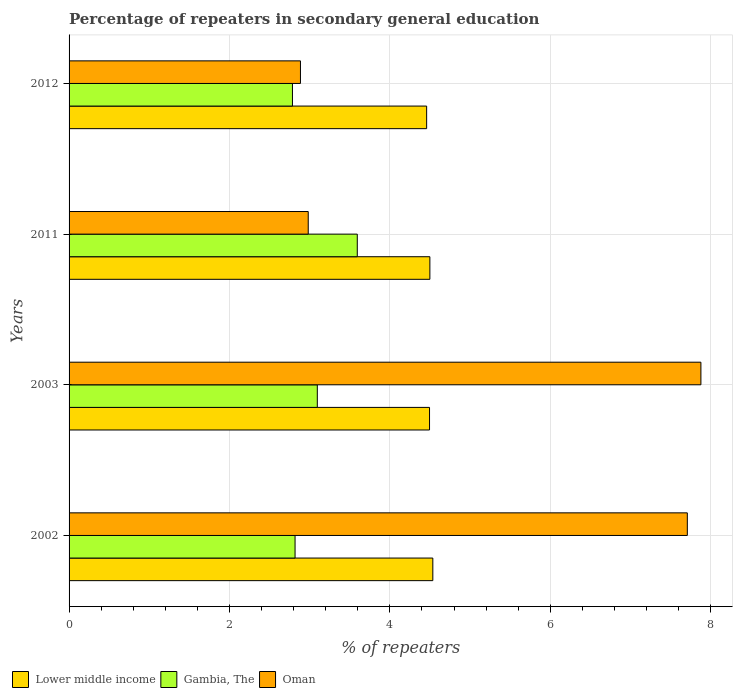How many different coloured bars are there?
Offer a terse response. 3. In how many cases, is the number of bars for a given year not equal to the number of legend labels?
Give a very brief answer. 0. What is the percentage of repeaters in secondary general education in Oman in 2012?
Ensure brevity in your answer.  2.89. Across all years, what is the maximum percentage of repeaters in secondary general education in Gambia, The?
Give a very brief answer. 3.59. Across all years, what is the minimum percentage of repeaters in secondary general education in Gambia, The?
Your answer should be compact. 2.79. In which year was the percentage of repeaters in secondary general education in Oman minimum?
Offer a terse response. 2012. What is the total percentage of repeaters in secondary general education in Gambia, The in the graph?
Ensure brevity in your answer.  12.29. What is the difference between the percentage of repeaters in secondary general education in Lower middle income in 2002 and that in 2011?
Keep it short and to the point. 0.04. What is the difference between the percentage of repeaters in secondary general education in Lower middle income in 2011 and the percentage of repeaters in secondary general education in Gambia, The in 2012?
Offer a terse response. 1.71. What is the average percentage of repeaters in secondary general education in Lower middle income per year?
Your answer should be compact. 4.5. In the year 2012, what is the difference between the percentage of repeaters in secondary general education in Lower middle income and percentage of repeaters in secondary general education in Oman?
Ensure brevity in your answer.  1.57. In how many years, is the percentage of repeaters in secondary general education in Lower middle income greater than 2 %?
Your response must be concise. 4. What is the ratio of the percentage of repeaters in secondary general education in Gambia, The in 2002 to that in 2012?
Your response must be concise. 1.01. Is the difference between the percentage of repeaters in secondary general education in Lower middle income in 2002 and 2012 greater than the difference between the percentage of repeaters in secondary general education in Oman in 2002 and 2012?
Offer a very short reply. No. What is the difference between the highest and the second highest percentage of repeaters in secondary general education in Gambia, The?
Make the answer very short. 0.5. What is the difference between the highest and the lowest percentage of repeaters in secondary general education in Lower middle income?
Give a very brief answer. 0.08. In how many years, is the percentage of repeaters in secondary general education in Oman greater than the average percentage of repeaters in secondary general education in Oman taken over all years?
Make the answer very short. 2. What does the 3rd bar from the top in 2003 represents?
Give a very brief answer. Lower middle income. What does the 3rd bar from the bottom in 2003 represents?
Provide a short and direct response. Oman. How many bars are there?
Make the answer very short. 12. Are all the bars in the graph horizontal?
Offer a very short reply. Yes. How many years are there in the graph?
Ensure brevity in your answer.  4. Does the graph contain any zero values?
Your response must be concise. No. Where does the legend appear in the graph?
Offer a terse response. Bottom left. How many legend labels are there?
Provide a succinct answer. 3. What is the title of the graph?
Ensure brevity in your answer.  Percentage of repeaters in secondary general education. Does "Luxembourg" appear as one of the legend labels in the graph?
Keep it short and to the point. No. What is the label or title of the X-axis?
Your answer should be very brief. % of repeaters. What is the % of repeaters of Lower middle income in 2002?
Give a very brief answer. 4.54. What is the % of repeaters in Gambia, The in 2002?
Keep it short and to the point. 2.82. What is the % of repeaters in Oman in 2002?
Make the answer very short. 7.71. What is the % of repeaters in Lower middle income in 2003?
Your answer should be compact. 4.49. What is the % of repeaters in Gambia, The in 2003?
Your answer should be compact. 3.1. What is the % of repeaters of Oman in 2003?
Offer a terse response. 7.88. What is the % of repeaters in Lower middle income in 2011?
Offer a very short reply. 4.5. What is the % of repeaters in Gambia, The in 2011?
Provide a short and direct response. 3.59. What is the % of repeaters in Oman in 2011?
Offer a terse response. 2.98. What is the % of repeaters of Lower middle income in 2012?
Ensure brevity in your answer.  4.46. What is the % of repeaters of Gambia, The in 2012?
Make the answer very short. 2.79. What is the % of repeaters of Oman in 2012?
Provide a short and direct response. 2.89. Across all years, what is the maximum % of repeaters in Lower middle income?
Give a very brief answer. 4.54. Across all years, what is the maximum % of repeaters of Gambia, The?
Make the answer very short. 3.59. Across all years, what is the maximum % of repeaters of Oman?
Make the answer very short. 7.88. Across all years, what is the minimum % of repeaters in Lower middle income?
Ensure brevity in your answer.  4.46. Across all years, what is the minimum % of repeaters in Gambia, The?
Make the answer very short. 2.79. Across all years, what is the minimum % of repeaters in Oman?
Offer a very short reply. 2.89. What is the total % of repeaters in Lower middle income in the graph?
Your response must be concise. 17.99. What is the total % of repeaters of Gambia, The in the graph?
Your response must be concise. 12.29. What is the total % of repeaters of Oman in the graph?
Your answer should be compact. 21.46. What is the difference between the % of repeaters of Lower middle income in 2002 and that in 2003?
Your response must be concise. 0.04. What is the difference between the % of repeaters of Gambia, The in 2002 and that in 2003?
Your response must be concise. -0.28. What is the difference between the % of repeaters of Oman in 2002 and that in 2003?
Your response must be concise. -0.17. What is the difference between the % of repeaters in Lower middle income in 2002 and that in 2011?
Offer a very short reply. 0.04. What is the difference between the % of repeaters in Gambia, The in 2002 and that in 2011?
Give a very brief answer. -0.78. What is the difference between the % of repeaters of Oman in 2002 and that in 2011?
Your response must be concise. 4.73. What is the difference between the % of repeaters of Lower middle income in 2002 and that in 2012?
Your answer should be compact. 0.08. What is the difference between the % of repeaters in Gambia, The in 2002 and that in 2012?
Provide a succinct answer. 0.03. What is the difference between the % of repeaters in Oman in 2002 and that in 2012?
Your response must be concise. 4.82. What is the difference between the % of repeaters of Lower middle income in 2003 and that in 2011?
Offer a terse response. -0. What is the difference between the % of repeaters in Gambia, The in 2003 and that in 2011?
Provide a short and direct response. -0.5. What is the difference between the % of repeaters in Oman in 2003 and that in 2011?
Ensure brevity in your answer.  4.9. What is the difference between the % of repeaters of Lower middle income in 2003 and that in 2012?
Provide a succinct answer. 0.04. What is the difference between the % of repeaters of Gambia, The in 2003 and that in 2012?
Provide a succinct answer. 0.31. What is the difference between the % of repeaters in Oman in 2003 and that in 2012?
Provide a succinct answer. 4.99. What is the difference between the % of repeaters of Lower middle income in 2011 and that in 2012?
Ensure brevity in your answer.  0.04. What is the difference between the % of repeaters in Gambia, The in 2011 and that in 2012?
Offer a very short reply. 0.81. What is the difference between the % of repeaters of Oman in 2011 and that in 2012?
Provide a succinct answer. 0.1. What is the difference between the % of repeaters in Lower middle income in 2002 and the % of repeaters in Gambia, The in 2003?
Give a very brief answer. 1.44. What is the difference between the % of repeaters of Lower middle income in 2002 and the % of repeaters of Oman in 2003?
Keep it short and to the point. -3.34. What is the difference between the % of repeaters of Gambia, The in 2002 and the % of repeaters of Oman in 2003?
Keep it short and to the point. -5.06. What is the difference between the % of repeaters in Lower middle income in 2002 and the % of repeaters in Gambia, The in 2011?
Your answer should be compact. 0.94. What is the difference between the % of repeaters in Lower middle income in 2002 and the % of repeaters in Oman in 2011?
Ensure brevity in your answer.  1.55. What is the difference between the % of repeaters of Gambia, The in 2002 and the % of repeaters of Oman in 2011?
Offer a very short reply. -0.16. What is the difference between the % of repeaters in Lower middle income in 2002 and the % of repeaters in Gambia, The in 2012?
Provide a succinct answer. 1.75. What is the difference between the % of repeaters in Lower middle income in 2002 and the % of repeaters in Oman in 2012?
Your response must be concise. 1.65. What is the difference between the % of repeaters in Gambia, The in 2002 and the % of repeaters in Oman in 2012?
Offer a terse response. -0.07. What is the difference between the % of repeaters of Lower middle income in 2003 and the % of repeaters of Gambia, The in 2011?
Provide a short and direct response. 0.9. What is the difference between the % of repeaters of Lower middle income in 2003 and the % of repeaters of Oman in 2011?
Give a very brief answer. 1.51. What is the difference between the % of repeaters in Gambia, The in 2003 and the % of repeaters in Oman in 2011?
Give a very brief answer. 0.11. What is the difference between the % of repeaters of Lower middle income in 2003 and the % of repeaters of Gambia, The in 2012?
Give a very brief answer. 1.71. What is the difference between the % of repeaters of Lower middle income in 2003 and the % of repeaters of Oman in 2012?
Make the answer very short. 1.61. What is the difference between the % of repeaters in Gambia, The in 2003 and the % of repeaters in Oman in 2012?
Your answer should be very brief. 0.21. What is the difference between the % of repeaters in Lower middle income in 2011 and the % of repeaters in Gambia, The in 2012?
Make the answer very short. 1.71. What is the difference between the % of repeaters of Lower middle income in 2011 and the % of repeaters of Oman in 2012?
Your answer should be compact. 1.61. What is the difference between the % of repeaters in Gambia, The in 2011 and the % of repeaters in Oman in 2012?
Keep it short and to the point. 0.71. What is the average % of repeaters of Lower middle income per year?
Give a very brief answer. 4.5. What is the average % of repeaters of Gambia, The per year?
Make the answer very short. 3.07. What is the average % of repeaters of Oman per year?
Your answer should be very brief. 5.36. In the year 2002, what is the difference between the % of repeaters in Lower middle income and % of repeaters in Gambia, The?
Provide a succinct answer. 1.72. In the year 2002, what is the difference between the % of repeaters of Lower middle income and % of repeaters of Oman?
Make the answer very short. -3.17. In the year 2002, what is the difference between the % of repeaters in Gambia, The and % of repeaters in Oman?
Keep it short and to the point. -4.89. In the year 2003, what is the difference between the % of repeaters of Lower middle income and % of repeaters of Gambia, The?
Offer a terse response. 1.4. In the year 2003, what is the difference between the % of repeaters of Lower middle income and % of repeaters of Oman?
Offer a very short reply. -3.38. In the year 2003, what is the difference between the % of repeaters in Gambia, The and % of repeaters in Oman?
Provide a succinct answer. -4.78. In the year 2011, what is the difference between the % of repeaters in Lower middle income and % of repeaters in Gambia, The?
Your response must be concise. 0.91. In the year 2011, what is the difference between the % of repeaters of Lower middle income and % of repeaters of Oman?
Make the answer very short. 1.52. In the year 2011, what is the difference between the % of repeaters of Gambia, The and % of repeaters of Oman?
Provide a short and direct response. 0.61. In the year 2012, what is the difference between the % of repeaters in Lower middle income and % of repeaters in Gambia, The?
Provide a short and direct response. 1.67. In the year 2012, what is the difference between the % of repeaters in Lower middle income and % of repeaters in Oman?
Offer a very short reply. 1.57. In the year 2012, what is the difference between the % of repeaters of Gambia, The and % of repeaters of Oman?
Give a very brief answer. -0.1. What is the ratio of the % of repeaters of Lower middle income in 2002 to that in 2003?
Make the answer very short. 1.01. What is the ratio of the % of repeaters of Gambia, The in 2002 to that in 2003?
Your answer should be very brief. 0.91. What is the ratio of the % of repeaters of Oman in 2002 to that in 2003?
Offer a very short reply. 0.98. What is the ratio of the % of repeaters in Lower middle income in 2002 to that in 2011?
Your answer should be very brief. 1.01. What is the ratio of the % of repeaters in Gambia, The in 2002 to that in 2011?
Your response must be concise. 0.78. What is the ratio of the % of repeaters of Oman in 2002 to that in 2011?
Offer a terse response. 2.58. What is the ratio of the % of repeaters in Lower middle income in 2002 to that in 2012?
Make the answer very short. 1.02. What is the ratio of the % of repeaters in Gambia, The in 2002 to that in 2012?
Your answer should be compact. 1.01. What is the ratio of the % of repeaters of Oman in 2002 to that in 2012?
Give a very brief answer. 2.67. What is the ratio of the % of repeaters in Lower middle income in 2003 to that in 2011?
Your answer should be very brief. 1. What is the ratio of the % of repeaters of Gambia, The in 2003 to that in 2011?
Keep it short and to the point. 0.86. What is the ratio of the % of repeaters in Oman in 2003 to that in 2011?
Provide a succinct answer. 2.64. What is the ratio of the % of repeaters in Lower middle income in 2003 to that in 2012?
Your response must be concise. 1.01. What is the ratio of the % of repeaters in Gambia, The in 2003 to that in 2012?
Provide a short and direct response. 1.11. What is the ratio of the % of repeaters of Oman in 2003 to that in 2012?
Offer a very short reply. 2.73. What is the ratio of the % of repeaters of Gambia, The in 2011 to that in 2012?
Offer a terse response. 1.29. What is the ratio of the % of repeaters of Oman in 2011 to that in 2012?
Make the answer very short. 1.03. What is the difference between the highest and the second highest % of repeaters in Lower middle income?
Your answer should be very brief. 0.04. What is the difference between the highest and the second highest % of repeaters in Gambia, The?
Your answer should be very brief. 0.5. What is the difference between the highest and the second highest % of repeaters in Oman?
Offer a very short reply. 0.17. What is the difference between the highest and the lowest % of repeaters in Lower middle income?
Your answer should be compact. 0.08. What is the difference between the highest and the lowest % of repeaters in Gambia, The?
Make the answer very short. 0.81. What is the difference between the highest and the lowest % of repeaters of Oman?
Provide a succinct answer. 4.99. 